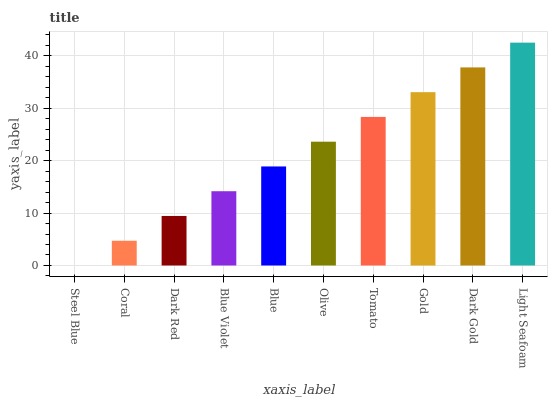Is Steel Blue the minimum?
Answer yes or no. Yes. Is Light Seafoam the maximum?
Answer yes or no. Yes. Is Coral the minimum?
Answer yes or no. No. Is Coral the maximum?
Answer yes or no. No. Is Coral greater than Steel Blue?
Answer yes or no. Yes. Is Steel Blue less than Coral?
Answer yes or no. Yes. Is Steel Blue greater than Coral?
Answer yes or no. No. Is Coral less than Steel Blue?
Answer yes or no. No. Is Olive the high median?
Answer yes or no. Yes. Is Blue the low median?
Answer yes or no. Yes. Is Coral the high median?
Answer yes or no. No. Is Dark Red the low median?
Answer yes or no. No. 